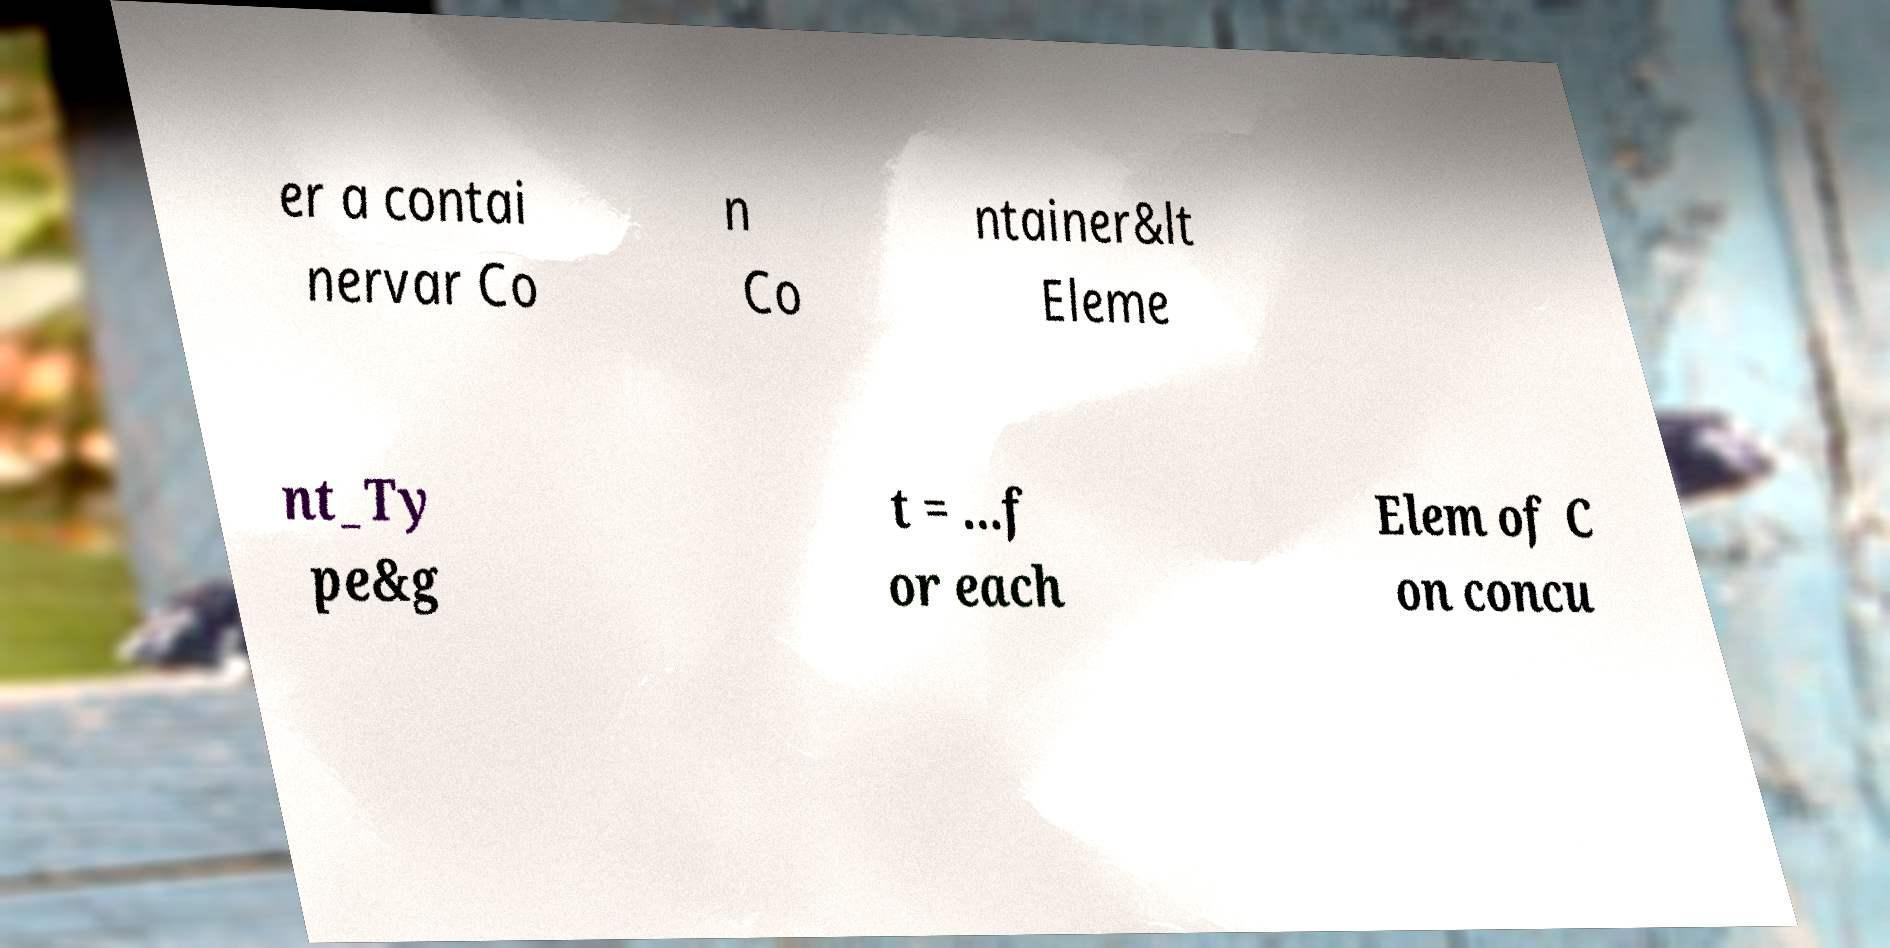Could you extract and type out the text from this image? er a contai nervar Co n Co ntainer&lt Eleme nt_Ty pe&g t = ...f or each Elem of C on concu 